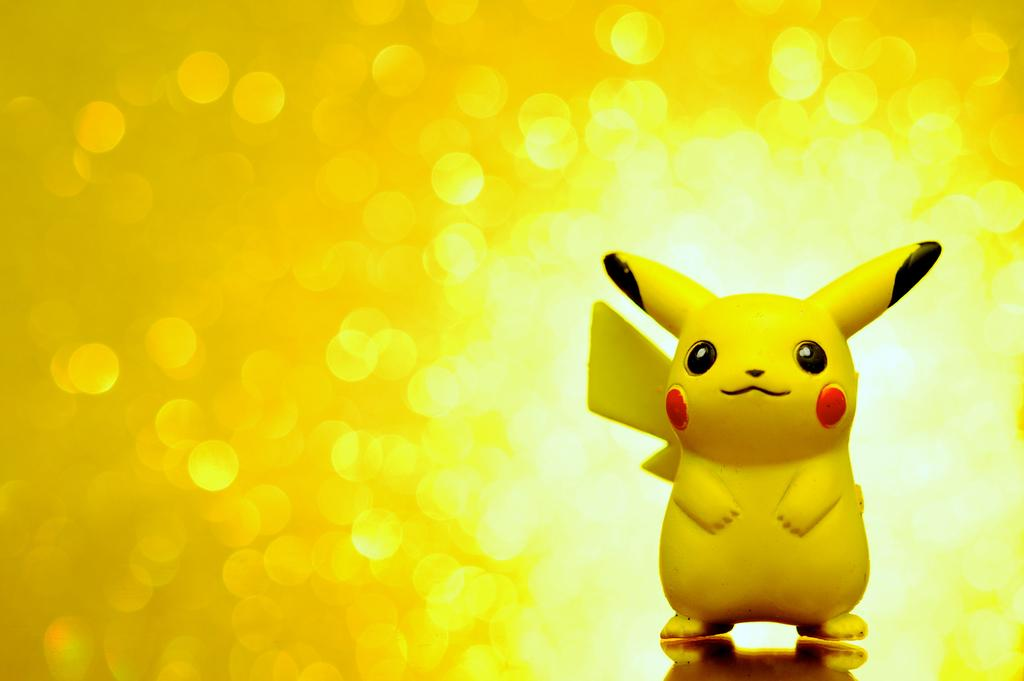What object can be seen in the image? There is a toy in the image. What color is the background of the image? The background of the image is yellow in color. Is the toy sinking in quicksand in the image? There is no quicksand present in the image, so the toy is not sinking in it. What mark is visible on the toy in the image? There is no mention of a mark on the toy in the provided facts, so we cannot determine if a mark is visible. 